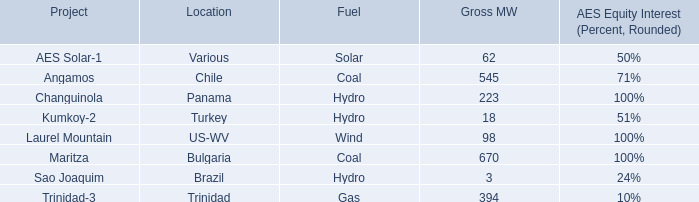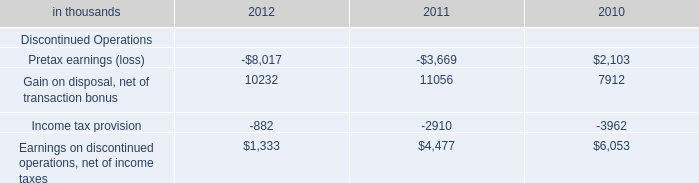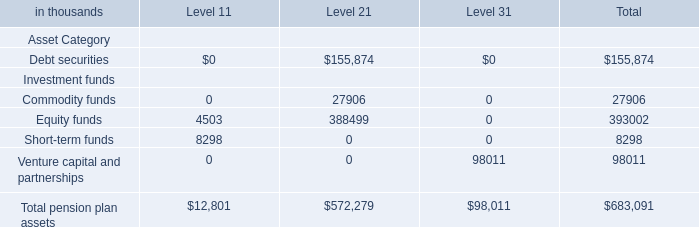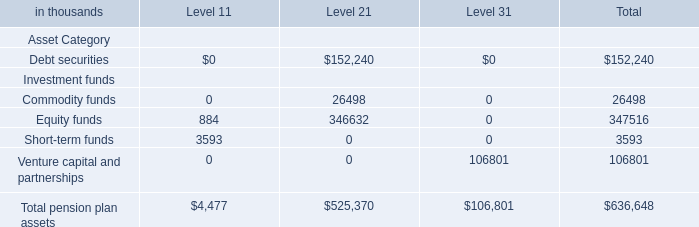What is the total amount of Earnings on discontinued operations, net of income taxes of 2011, and Equity funds Investment funds of Level 1 ? 
Computations: (4477.0 + 4503.0)
Answer: 8980.0. 